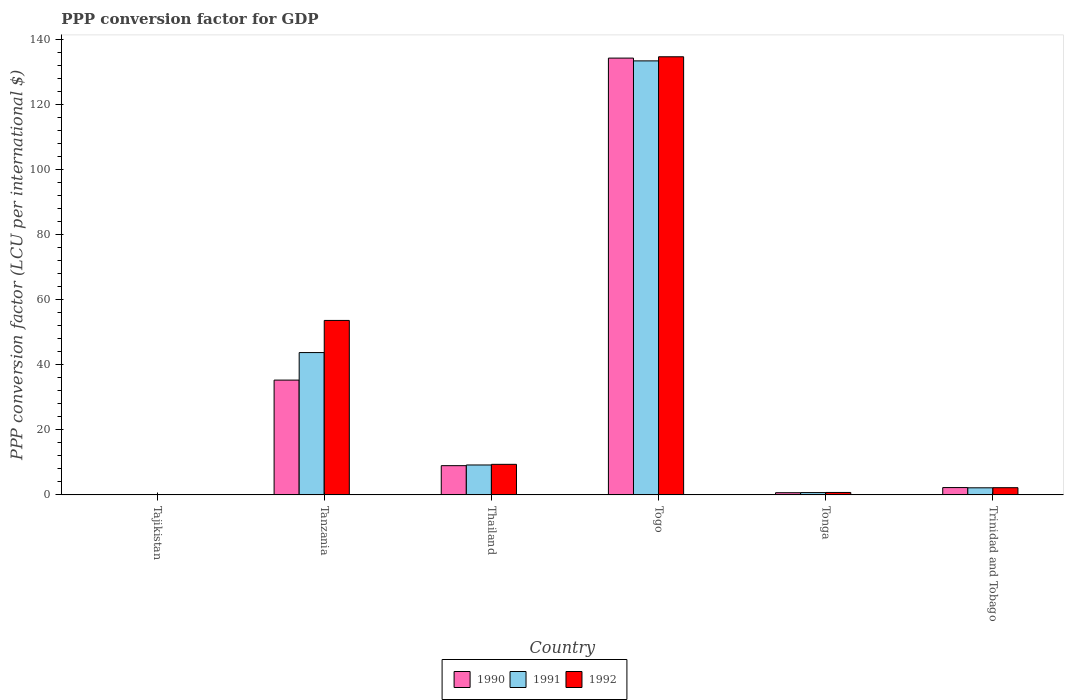How many different coloured bars are there?
Your answer should be very brief. 3. How many groups of bars are there?
Ensure brevity in your answer.  6. Are the number of bars per tick equal to the number of legend labels?
Keep it short and to the point. Yes. Are the number of bars on each tick of the X-axis equal?
Your response must be concise. Yes. How many bars are there on the 5th tick from the left?
Offer a very short reply. 3. What is the label of the 4th group of bars from the left?
Your response must be concise. Togo. What is the PPP conversion factor for GDP in 1992 in Tajikistan?
Provide a short and direct response. 7.45704164810197e-5. Across all countries, what is the maximum PPP conversion factor for GDP in 1992?
Your answer should be compact. 134.57. Across all countries, what is the minimum PPP conversion factor for GDP in 1991?
Your answer should be very brief. 1.13195054998771e-5. In which country was the PPP conversion factor for GDP in 1992 maximum?
Your response must be concise. Togo. In which country was the PPP conversion factor for GDP in 1990 minimum?
Provide a succinct answer. Tajikistan. What is the total PPP conversion factor for GDP in 1990 in the graph?
Your answer should be very brief. 181.32. What is the difference between the PPP conversion factor for GDP in 1992 in Tajikistan and that in Thailand?
Ensure brevity in your answer.  -9.39. What is the difference between the PPP conversion factor for GDP in 1992 in Togo and the PPP conversion factor for GDP in 1991 in Tajikistan?
Your answer should be compact. 134.57. What is the average PPP conversion factor for GDP in 1992 per country?
Make the answer very short. 33.42. What is the difference between the PPP conversion factor for GDP of/in 1990 and PPP conversion factor for GDP of/in 1992 in Tonga?
Your answer should be compact. -0.08. What is the ratio of the PPP conversion factor for GDP in 1992 in Tonga to that in Trinidad and Tobago?
Your answer should be very brief. 0.34. What is the difference between the highest and the second highest PPP conversion factor for GDP in 1991?
Make the answer very short. -34.53. What is the difference between the highest and the lowest PPP conversion factor for GDP in 1990?
Offer a very short reply. 134.16. Is the sum of the PPP conversion factor for GDP in 1991 in Tanzania and Togo greater than the maximum PPP conversion factor for GDP in 1992 across all countries?
Offer a terse response. Yes. What does the 2nd bar from the left in Togo represents?
Provide a short and direct response. 1991. What does the 1st bar from the right in Tanzania represents?
Ensure brevity in your answer.  1992. Are all the bars in the graph horizontal?
Ensure brevity in your answer.  No. Does the graph contain any zero values?
Your answer should be compact. No. Where does the legend appear in the graph?
Your answer should be compact. Bottom center. How many legend labels are there?
Ensure brevity in your answer.  3. How are the legend labels stacked?
Give a very brief answer. Horizontal. What is the title of the graph?
Give a very brief answer. PPP conversion factor for GDP. What is the label or title of the X-axis?
Offer a terse response. Country. What is the label or title of the Y-axis?
Give a very brief answer. PPP conversion factor (LCU per international $). What is the PPP conversion factor (LCU per international $) in 1990 in Tajikistan?
Your answer should be very brief. 5.85696825200666e-6. What is the PPP conversion factor (LCU per international $) in 1991 in Tajikistan?
Make the answer very short. 1.13195054998771e-5. What is the PPP conversion factor (LCU per international $) of 1992 in Tajikistan?
Give a very brief answer. 7.45704164810197e-5. What is the PPP conversion factor (LCU per international $) in 1990 in Tanzania?
Provide a short and direct response. 35.26. What is the PPP conversion factor (LCU per international $) in 1991 in Tanzania?
Your answer should be very brief. 43.72. What is the PPP conversion factor (LCU per international $) of 1992 in Tanzania?
Give a very brief answer. 53.59. What is the PPP conversion factor (LCU per international $) in 1990 in Thailand?
Ensure brevity in your answer.  8.98. What is the PPP conversion factor (LCU per international $) of 1991 in Thailand?
Ensure brevity in your answer.  9.19. What is the PPP conversion factor (LCU per international $) in 1992 in Thailand?
Provide a succinct answer. 9.39. What is the PPP conversion factor (LCU per international $) of 1990 in Togo?
Provide a succinct answer. 134.16. What is the PPP conversion factor (LCU per international $) in 1991 in Togo?
Provide a short and direct response. 133.31. What is the PPP conversion factor (LCU per international $) in 1992 in Togo?
Your answer should be compact. 134.57. What is the PPP conversion factor (LCU per international $) in 1990 in Tonga?
Provide a succinct answer. 0.67. What is the PPP conversion factor (LCU per international $) of 1991 in Tonga?
Ensure brevity in your answer.  0.71. What is the PPP conversion factor (LCU per international $) in 1992 in Tonga?
Make the answer very short. 0.75. What is the PPP conversion factor (LCU per international $) in 1990 in Trinidad and Tobago?
Your response must be concise. 2.25. What is the PPP conversion factor (LCU per international $) of 1991 in Trinidad and Tobago?
Make the answer very short. 2.18. What is the PPP conversion factor (LCU per international $) in 1992 in Trinidad and Tobago?
Offer a terse response. 2.21. Across all countries, what is the maximum PPP conversion factor (LCU per international $) of 1990?
Ensure brevity in your answer.  134.16. Across all countries, what is the maximum PPP conversion factor (LCU per international $) of 1991?
Give a very brief answer. 133.31. Across all countries, what is the maximum PPP conversion factor (LCU per international $) of 1992?
Provide a short and direct response. 134.57. Across all countries, what is the minimum PPP conversion factor (LCU per international $) in 1990?
Offer a terse response. 5.85696825200666e-6. Across all countries, what is the minimum PPP conversion factor (LCU per international $) in 1991?
Your answer should be compact. 1.13195054998771e-5. Across all countries, what is the minimum PPP conversion factor (LCU per international $) of 1992?
Keep it short and to the point. 7.45704164810197e-5. What is the total PPP conversion factor (LCU per international $) of 1990 in the graph?
Provide a succinct answer. 181.32. What is the total PPP conversion factor (LCU per international $) in 1991 in the graph?
Make the answer very short. 189.1. What is the total PPP conversion factor (LCU per international $) in 1992 in the graph?
Your answer should be very brief. 200.5. What is the difference between the PPP conversion factor (LCU per international $) in 1990 in Tajikistan and that in Tanzania?
Offer a very short reply. -35.26. What is the difference between the PPP conversion factor (LCU per international $) in 1991 in Tajikistan and that in Tanzania?
Offer a terse response. -43.72. What is the difference between the PPP conversion factor (LCU per international $) in 1992 in Tajikistan and that in Tanzania?
Give a very brief answer. -53.59. What is the difference between the PPP conversion factor (LCU per international $) in 1990 in Tajikistan and that in Thailand?
Give a very brief answer. -8.98. What is the difference between the PPP conversion factor (LCU per international $) of 1991 in Tajikistan and that in Thailand?
Offer a terse response. -9.19. What is the difference between the PPP conversion factor (LCU per international $) of 1992 in Tajikistan and that in Thailand?
Provide a succinct answer. -9.39. What is the difference between the PPP conversion factor (LCU per international $) in 1990 in Tajikistan and that in Togo?
Give a very brief answer. -134.16. What is the difference between the PPP conversion factor (LCU per international $) in 1991 in Tajikistan and that in Togo?
Your response must be concise. -133.31. What is the difference between the PPP conversion factor (LCU per international $) in 1992 in Tajikistan and that in Togo?
Keep it short and to the point. -134.57. What is the difference between the PPP conversion factor (LCU per international $) of 1990 in Tajikistan and that in Tonga?
Your answer should be very brief. -0.67. What is the difference between the PPP conversion factor (LCU per international $) in 1991 in Tajikistan and that in Tonga?
Make the answer very short. -0.71. What is the difference between the PPP conversion factor (LCU per international $) of 1992 in Tajikistan and that in Tonga?
Keep it short and to the point. -0.75. What is the difference between the PPP conversion factor (LCU per international $) of 1990 in Tajikistan and that in Trinidad and Tobago?
Your answer should be very brief. -2.25. What is the difference between the PPP conversion factor (LCU per international $) in 1991 in Tajikistan and that in Trinidad and Tobago?
Your answer should be compact. -2.18. What is the difference between the PPP conversion factor (LCU per international $) of 1992 in Tajikistan and that in Trinidad and Tobago?
Your response must be concise. -2.21. What is the difference between the PPP conversion factor (LCU per international $) of 1990 in Tanzania and that in Thailand?
Give a very brief answer. 26.28. What is the difference between the PPP conversion factor (LCU per international $) in 1991 in Tanzania and that in Thailand?
Ensure brevity in your answer.  34.53. What is the difference between the PPP conversion factor (LCU per international $) of 1992 in Tanzania and that in Thailand?
Provide a succinct answer. 44.2. What is the difference between the PPP conversion factor (LCU per international $) in 1990 in Tanzania and that in Togo?
Your response must be concise. -98.91. What is the difference between the PPP conversion factor (LCU per international $) in 1991 in Tanzania and that in Togo?
Keep it short and to the point. -89.6. What is the difference between the PPP conversion factor (LCU per international $) in 1992 in Tanzania and that in Togo?
Provide a succinct answer. -80.98. What is the difference between the PPP conversion factor (LCU per international $) in 1990 in Tanzania and that in Tonga?
Your response must be concise. 34.59. What is the difference between the PPP conversion factor (LCU per international $) of 1991 in Tanzania and that in Tonga?
Provide a succinct answer. 43.01. What is the difference between the PPP conversion factor (LCU per international $) of 1992 in Tanzania and that in Tonga?
Ensure brevity in your answer.  52.84. What is the difference between the PPP conversion factor (LCU per international $) in 1990 in Tanzania and that in Trinidad and Tobago?
Give a very brief answer. 33.01. What is the difference between the PPP conversion factor (LCU per international $) in 1991 in Tanzania and that in Trinidad and Tobago?
Ensure brevity in your answer.  41.54. What is the difference between the PPP conversion factor (LCU per international $) of 1992 in Tanzania and that in Trinidad and Tobago?
Your answer should be compact. 51.38. What is the difference between the PPP conversion factor (LCU per international $) in 1990 in Thailand and that in Togo?
Make the answer very short. -125.19. What is the difference between the PPP conversion factor (LCU per international $) of 1991 in Thailand and that in Togo?
Offer a very short reply. -124.12. What is the difference between the PPP conversion factor (LCU per international $) of 1992 in Thailand and that in Togo?
Give a very brief answer. -125.18. What is the difference between the PPP conversion factor (LCU per international $) in 1990 in Thailand and that in Tonga?
Ensure brevity in your answer.  8.31. What is the difference between the PPP conversion factor (LCU per international $) of 1991 in Thailand and that in Tonga?
Your answer should be compact. 8.48. What is the difference between the PPP conversion factor (LCU per international $) in 1992 in Thailand and that in Tonga?
Provide a succinct answer. 8.64. What is the difference between the PPP conversion factor (LCU per international $) in 1990 in Thailand and that in Trinidad and Tobago?
Provide a succinct answer. 6.73. What is the difference between the PPP conversion factor (LCU per international $) in 1991 in Thailand and that in Trinidad and Tobago?
Give a very brief answer. 7.01. What is the difference between the PPP conversion factor (LCU per international $) in 1992 in Thailand and that in Trinidad and Tobago?
Your answer should be very brief. 7.18. What is the difference between the PPP conversion factor (LCU per international $) in 1990 in Togo and that in Tonga?
Your answer should be compact. 133.5. What is the difference between the PPP conversion factor (LCU per international $) of 1991 in Togo and that in Tonga?
Ensure brevity in your answer.  132.6. What is the difference between the PPP conversion factor (LCU per international $) of 1992 in Togo and that in Tonga?
Keep it short and to the point. 133.82. What is the difference between the PPP conversion factor (LCU per international $) of 1990 in Togo and that in Trinidad and Tobago?
Keep it short and to the point. 131.92. What is the difference between the PPP conversion factor (LCU per international $) of 1991 in Togo and that in Trinidad and Tobago?
Offer a very short reply. 131.14. What is the difference between the PPP conversion factor (LCU per international $) of 1992 in Togo and that in Trinidad and Tobago?
Offer a terse response. 132.36. What is the difference between the PPP conversion factor (LCU per international $) in 1990 in Tonga and that in Trinidad and Tobago?
Offer a very short reply. -1.58. What is the difference between the PPP conversion factor (LCU per international $) of 1991 in Tonga and that in Trinidad and Tobago?
Your answer should be very brief. -1.47. What is the difference between the PPP conversion factor (LCU per international $) in 1992 in Tonga and that in Trinidad and Tobago?
Provide a short and direct response. -1.47. What is the difference between the PPP conversion factor (LCU per international $) of 1990 in Tajikistan and the PPP conversion factor (LCU per international $) of 1991 in Tanzania?
Your response must be concise. -43.72. What is the difference between the PPP conversion factor (LCU per international $) in 1990 in Tajikistan and the PPP conversion factor (LCU per international $) in 1992 in Tanzania?
Offer a very short reply. -53.59. What is the difference between the PPP conversion factor (LCU per international $) in 1991 in Tajikistan and the PPP conversion factor (LCU per international $) in 1992 in Tanzania?
Your response must be concise. -53.59. What is the difference between the PPP conversion factor (LCU per international $) in 1990 in Tajikistan and the PPP conversion factor (LCU per international $) in 1991 in Thailand?
Offer a very short reply. -9.19. What is the difference between the PPP conversion factor (LCU per international $) of 1990 in Tajikistan and the PPP conversion factor (LCU per international $) of 1992 in Thailand?
Your response must be concise. -9.39. What is the difference between the PPP conversion factor (LCU per international $) in 1991 in Tajikistan and the PPP conversion factor (LCU per international $) in 1992 in Thailand?
Offer a terse response. -9.39. What is the difference between the PPP conversion factor (LCU per international $) of 1990 in Tajikistan and the PPP conversion factor (LCU per international $) of 1991 in Togo?
Your response must be concise. -133.31. What is the difference between the PPP conversion factor (LCU per international $) of 1990 in Tajikistan and the PPP conversion factor (LCU per international $) of 1992 in Togo?
Make the answer very short. -134.57. What is the difference between the PPP conversion factor (LCU per international $) of 1991 in Tajikistan and the PPP conversion factor (LCU per international $) of 1992 in Togo?
Make the answer very short. -134.57. What is the difference between the PPP conversion factor (LCU per international $) of 1990 in Tajikistan and the PPP conversion factor (LCU per international $) of 1991 in Tonga?
Make the answer very short. -0.71. What is the difference between the PPP conversion factor (LCU per international $) in 1990 in Tajikistan and the PPP conversion factor (LCU per international $) in 1992 in Tonga?
Keep it short and to the point. -0.75. What is the difference between the PPP conversion factor (LCU per international $) in 1991 in Tajikistan and the PPP conversion factor (LCU per international $) in 1992 in Tonga?
Your response must be concise. -0.75. What is the difference between the PPP conversion factor (LCU per international $) in 1990 in Tajikistan and the PPP conversion factor (LCU per international $) in 1991 in Trinidad and Tobago?
Ensure brevity in your answer.  -2.18. What is the difference between the PPP conversion factor (LCU per international $) of 1990 in Tajikistan and the PPP conversion factor (LCU per international $) of 1992 in Trinidad and Tobago?
Offer a terse response. -2.21. What is the difference between the PPP conversion factor (LCU per international $) in 1991 in Tajikistan and the PPP conversion factor (LCU per international $) in 1992 in Trinidad and Tobago?
Provide a succinct answer. -2.21. What is the difference between the PPP conversion factor (LCU per international $) in 1990 in Tanzania and the PPP conversion factor (LCU per international $) in 1991 in Thailand?
Offer a terse response. 26.07. What is the difference between the PPP conversion factor (LCU per international $) of 1990 in Tanzania and the PPP conversion factor (LCU per international $) of 1992 in Thailand?
Offer a very short reply. 25.87. What is the difference between the PPP conversion factor (LCU per international $) in 1991 in Tanzania and the PPP conversion factor (LCU per international $) in 1992 in Thailand?
Provide a short and direct response. 34.33. What is the difference between the PPP conversion factor (LCU per international $) in 1990 in Tanzania and the PPP conversion factor (LCU per international $) in 1991 in Togo?
Keep it short and to the point. -98.05. What is the difference between the PPP conversion factor (LCU per international $) in 1990 in Tanzania and the PPP conversion factor (LCU per international $) in 1992 in Togo?
Give a very brief answer. -99.31. What is the difference between the PPP conversion factor (LCU per international $) in 1991 in Tanzania and the PPP conversion factor (LCU per international $) in 1992 in Togo?
Offer a terse response. -90.85. What is the difference between the PPP conversion factor (LCU per international $) of 1990 in Tanzania and the PPP conversion factor (LCU per international $) of 1991 in Tonga?
Provide a short and direct response. 34.55. What is the difference between the PPP conversion factor (LCU per international $) in 1990 in Tanzania and the PPP conversion factor (LCU per international $) in 1992 in Tonga?
Offer a terse response. 34.51. What is the difference between the PPP conversion factor (LCU per international $) of 1991 in Tanzania and the PPP conversion factor (LCU per international $) of 1992 in Tonga?
Give a very brief answer. 42.97. What is the difference between the PPP conversion factor (LCU per international $) of 1990 in Tanzania and the PPP conversion factor (LCU per international $) of 1991 in Trinidad and Tobago?
Provide a short and direct response. 33.08. What is the difference between the PPP conversion factor (LCU per international $) of 1990 in Tanzania and the PPP conversion factor (LCU per international $) of 1992 in Trinidad and Tobago?
Provide a succinct answer. 33.05. What is the difference between the PPP conversion factor (LCU per international $) in 1991 in Tanzania and the PPP conversion factor (LCU per international $) in 1992 in Trinidad and Tobago?
Ensure brevity in your answer.  41.5. What is the difference between the PPP conversion factor (LCU per international $) in 1990 in Thailand and the PPP conversion factor (LCU per international $) in 1991 in Togo?
Keep it short and to the point. -124.33. What is the difference between the PPP conversion factor (LCU per international $) in 1990 in Thailand and the PPP conversion factor (LCU per international $) in 1992 in Togo?
Make the answer very short. -125.59. What is the difference between the PPP conversion factor (LCU per international $) of 1991 in Thailand and the PPP conversion factor (LCU per international $) of 1992 in Togo?
Provide a succinct answer. -125.38. What is the difference between the PPP conversion factor (LCU per international $) in 1990 in Thailand and the PPP conversion factor (LCU per international $) in 1991 in Tonga?
Provide a short and direct response. 8.27. What is the difference between the PPP conversion factor (LCU per international $) in 1990 in Thailand and the PPP conversion factor (LCU per international $) in 1992 in Tonga?
Ensure brevity in your answer.  8.23. What is the difference between the PPP conversion factor (LCU per international $) of 1991 in Thailand and the PPP conversion factor (LCU per international $) of 1992 in Tonga?
Give a very brief answer. 8.44. What is the difference between the PPP conversion factor (LCU per international $) in 1990 in Thailand and the PPP conversion factor (LCU per international $) in 1991 in Trinidad and Tobago?
Ensure brevity in your answer.  6.8. What is the difference between the PPP conversion factor (LCU per international $) in 1990 in Thailand and the PPP conversion factor (LCU per international $) in 1992 in Trinidad and Tobago?
Provide a short and direct response. 6.77. What is the difference between the PPP conversion factor (LCU per international $) in 1991 in Thailand and the PPP conversion factor (LCU per international $) in 1992 in Trinidad and Tobago?
Offer a terse response. 6.98. What is the difference between the PPP conversion factor (LCU per international $) in 1990 in Togo and the PPP conversion factor (LCU per international $) in 1991 in Tonga?
Give a very brief answer. 133.46. What is the difference between the PPP conversion factor (LCU per international $) in 1990 in Togo and the PPP conversion factor (LCU per international $) in 1992 in Tonga?
Your response must be concise. 133.42. What is the difference between the PPP conversion factor (LCU per international $) in 1991 in Togo and the PPP conversion factor (LCU per international $) in 1992 in Tonga?
Provide a short and direct response. 132.57. What is the difference between the PPP conversion factor (LCU per international $) in 1990 in Togo and the PPP conversion factor (LCU per international $) in 1991 in Trinidad and Tobago?
Your answer should be compact. 131.99. What is the difference between the PPP conversion factor (LCU per international $) in 1990 in Togo and the PPP conversion factor (LCU per international $) in 1992 in Trinidad and Tobago?
Provide a succinct answer. 131.95. What is the difference between the PPP conversion factor (LCU per international $) in 1991 in Togo and the PPP conversion factor (LCU per international $) in 1992 in Trinidad and Tobago?
Your answer should be very brief. 131.1. What is the difference between the PPP conversion factor (LCU per international $) in 1990 in Tonga and the PPP conversion factor (LCU per international $) in 1991 in Trinidad and Tobago?
Your answer should be compact. -1.51. What is the difference between the PPP conversion factor (LCU per international $) in 1990 in Tonga and the PPP conversion factor (LCU per international $) in 1992 in Trinidad and Tobago?
Give a very brief answer. -1.54. What is the difference between the PPP conversion factor (LCU per international $) in 1991 in Tonga and the PPP conversion factor (LCU per international $) in 1992 in Trinidad and Tobago?
Ensure brevity in your answer.  -1.5. What is the average PPP conversion factor (LCU per international $) in 1990 per country?
Give a very brief answer. 30.22. What is the average PPP conversion factor (LCU per international $) of 1991 per country?
Keep it short and to the point. 31.52. What is the average PPP conversion factor (LCU per international $) of 1992 per country?
Provide a succinct answer. 33.42. What is the difference between the PPP conversion factor (LCU per international $) of 1990 and PPP conversion factor (LCU per international $) of 1992 in Tajikistan?
Offer a terse response. -0. What is the difference between the PPP conversion factor (LCU per international $) in 1991 and PPP conversion factor (LCU per international $) in 1992 in Tajikistan?
Your answer should be very brief. -0. What is the difference between the PPP conversion factor (LCU per international $) of 1990 and PPP conversion factor (LCU per international $) of 1991 in Tanzania?
Your answer should be very brief. -8.46. What is the difference between the PPP conversion factor (LCU per international $) in 1990 and PPP conversion factor (LCU per international $) in 1992 in Tanzania?
Provide a succinct answer. -18.33. What is the difference between the PPP conversion factor (LCU per international $) in 1991 and PPP conversion factor (LCU per international $) in 1992 in Tanzania?
Offer a very short reply. -9.87. What is the difference between the PPP conversion factor (LCU per international $) in 1990 and PPP conversion factor (LCU per international $) in 1991 in Thailand?
Keep it short and to the point. -0.21. What is the difference between the PPP conversion factor (LCU per international $) of 1990 and PPP conversion factor (LCU per international $) of 1992 in Thailand?
Provide a short and direct response. -0.41. What is the difference between the PPP conversion factor (LCU per international $) in 1991 and PPP conversion factor (LCU per international $) in 1992 in Thailand?
Offer a terse response. -0.2. What is the difference between the PPP conversion factor (LCU per international $) in 1990 and PPP conversion factor (LCU per international $) in 1991 in Togo?
Your answer should be very brief. 0.85. What is the difference between the PPP conversion factor (LCU per international $) in 1990 and PPP conversion factor (LCU per international $) in 1992 in Togo?
Offer a very short reply. -0.41. What is the difference between the PPP conversion factor (LCU per international $) in 1991 and PPP conversion factor (LCU per international $) in 1992 in Togo?
Keep it short and to the point. -1.26. What is the difference between the PPP conversion factor (LCU per international $) of 1990 and PPP conversion factor (LCU per international $) of 1991 in Tonga?
Offer a terse response. -0.04. What is the difference between the PPP conversion factor (LCU per international $) of 1990 and PPP conversion factor (LCU per international $) of 1992 in Tonga?
Provide a short and direct response. -0.08. What is the difference between the PPP conversion factor (LCU per international $) in 1991 and PPP conversion factor (LCU per international $) in 1992 in Tonga?
Ensure brevity in your answer.  -0.04. What is the difference between the PPP conversion factor (LCU per international $) of 1990 and PPP conversion factor (LCU per international $) of 1991 in Trinidad and Tobago?
Make the answer very short. 0.07. What is the difference between the PPP conversion factor (LCU per international $) of 1990 and PPP conversion factor (LCU per international $) of 1992 in Trinidad and Tobago?
Keep it short and to the point. 0.04. What is the difference between the PPP conversion factor (LCU per international $) in 1991 and PPP conversion factor (LCU per international $) in 1992 in Trinidad and Tobago?
Give a very brief answer. -0.04. What is the ratio of the PPP conversion factor (LCU per international $) in 1992 in Tajikistan to that in Tanzania?
Your response must be concise. 0. What is the ratio of the PPP conversion factor (LCU per international $) in 1991 in Tajikistan to that in Thailand?
Offer a very short reply. 0. What is the ratio of the PPP conversion factor (LCU per international $) in 1991 in Tajikistan to that in Togo?
Your answer should be compact. 0. What is the ratio of the PPP conversion factor (LCU per international $) in 1990 in Tajikistan to that in Trinidad and Tobago?
Provide a short and direct response. 0. What is the ratio of the PPP conversion factor (LCU per international $) of 1991 in Tajikistan to that in Trinidad and Tobago?
Give a very brief answer. 0. What is the ratio of the PPP conversion factor (LCU per international $) in 1992 in Tajikistan to that in Trinidad and Tobago?
Make the answer very short. 0. What is the ratio of the PPP conversion factor (LCU per international $) in 1990 in Tanzania to that in Thailand?
Your answer should be very brief. 3.93. What is the ratio of the PPP conversion factor (LCU per international $) in 1991 in Tanzania to that in Thailand?
Provide a succinct answer. 4.76. What is the ratio of the PPP conversion factor (LCU per international $) of 1992 in Tanzania to that in Thailand?
Your response must be concise. 5.71. What is the ratio of the PPP conversion factor (LCU per international $) of 1990 in Tanzania to that in Togo?
Offer a terse response. 0.26. What is the ratio of the PPP conversion factor (LCU per international $) of 1991 in Tanzania to that in Togo?
Give a very brief answer. 0.33. What is the ratio of the PPP conversion factor (LCU per international $) in 1992 in Tanzania to that in Togo?
Ensure brevity in your answer.  0.4. What is the ratio of the PPP conversion factor (LCU per international $) in 1990 in Tanzania to that in Tonga?
Ensure brevity in your answer.  52.64. What is the ratio of the PPP conversion factor (LCU per international $) of 1991 in Tanzania to that in Tonga?
Keep it short and to the point. 61.61. What is the ratio of the PPP conversion factor (LCU per international $) in 1992 in Tanzania to that in Tonga?
Offer a terse response. 71.89. What is the ratio of the PPP conversion factor (LCU per international $) in 1990 in Tanzania to that in Trinidad and Tobago?
Your answer should be very brief. 15.68. What is the ratio of the PPP conversion factor (LCU per international $) in 1991 in Tanzania to that in Trinidad and Tobago?
Make the answer very short. 20.09. What is the ratio of the PPP conversion factor (LCU per international $) in 1992 in Tanzania to that in Trinidad and Tobago?
Your answer should be very brief. 24.24. What is the ratio of the PPP conversion factor (LCU per international $) of 1990 in Thailand to that in Togo?
Offer a very short reply. 0.07. What is the ratio of the PPP conversion factor (LCU per international $) of 1991 in Thailand to that in Togo?
Make the answer very short. 0.07. What is the ratio of the PPP conversion factor (LCU per international $) of 1992 in Thailand to that in Togo?
Provide a short and direct response. 0.07. What is the ratio of the PPP conversion factor (LCU per international $) of 1990 in Thailand to that in Tonga?
Make the answer very short. 13.4. What is the ratio of the PPP conversion factor (LCU per international $) in 1991 in Thailand to that in Tonga?
Your answer should be very brief. 12.95. What is the ratio of the PPP conversion factor (LCU per international $) of 1992 in Thailand to that in Tonga?
Provide a short and direct response. 12.59. What is the ratio of the PPP conversion factor (LCU per international $) in 1990 in Thailand to that in Trinidad and Tobago?
Offer a terse response. 3.99. What is the ratio of the PPP conversion factor (LCU per international $) of 1991 in Thailand to that in Trinidad and Tobago?
Make the answer very short. 4.22. What is the ratio of the PPP conversion factor (LCU per international $) in 1992 in Thailand to that in Trinidad and Tobago?
Your answer should be compact. 4.25. What is the ratio of the PPP conversion factor (LCU per international $) of 1990 in Togo to that in Tonga?
Give a very brief answer. 200.31. What is the ratio of the PPP conversion factor (LCU per international $) in 1991 in Togo to that in Tonga?
Provide a short and direct response. 187.88. What is the ratio of the PPP conversion factor (LCU per international $) of 1992 in Togo to that in Tonga?
Keep it short and to the point. 180.53. What is the ratio of the PPP conversion factor (LCU per international $) of 1990 in Togo to that in Trinidad and Tobago?
Offer a very short reply. 59.66. What is the ratio of the PPP conversion factor (LCU per international $) of 1991 in Togo to that in Trinidad and Tobago?
Give a very brief answer. 61.26. What is the ratio of the PPP conversion factor (LCU per international $) in 1992 in Togo to that in Trinidad and Tobago?
Your response must be concise. 60.86. What is the ratio of the PPP conversion factor (LCU per international $) in 1990 in Tonga to that in Trinidad and Tobago?
Provide a succinct answer. 0.3. What is the ratio of the PPP conversion factor (LCU per international $) of 1991 in Tonga to that in Trinidad and Tobago?
Offer a terse response. 0.33. What is the ratio of the PPP conversion factor (LCU per international $) of 1992 in Tonga to that in Trinidad and Tobago?
Offer a terse response. 0.34. What is the difference between the highest and the second highest PPP conversion factor (LCU per international $) in 1990?
Your response must be concise. 98.91. What is the difference between the highest and the second highest PPP conversion factor (LCU per international $) of 1991?
Give a very brief answer. 89.6. What is the difference between the highest and the second highest PPP conversion factor (LCU per international $) of 1992?
Your answer should be very brief. 80.98. What is the difference between the highest and the lowest PPP conversion factor (LCU per international $) in 1990?
Provide a short and direct response. 134.16. What is the difference between the highest and the lowest PPP conversion factor (LCU per international $) of 1991?
Your response must be concise. 133.31. What is the difference between the highest and the lowest PPP conversion factor (LCU per international $) in 1992?
Offer a terse response. 134.57. 